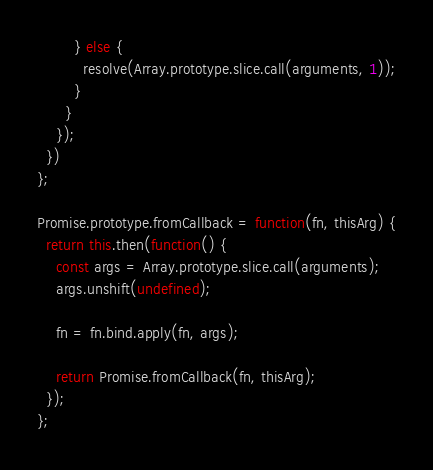Convert code to text. <code><loc_0><loc_0><loc_500><loc_500><_JavaScript_>        } else {
          resolve(Array.prototype.slice.call(arguments, 1));
        }
      }
    });
  })
};

Promise.prototype.fromCallback = function(fn, thisArg) {
  return this.then(function() {
    const args = Array.prototype.slice.call(arguments);
    args.unshift(undefined);

    fn = fn.bind.apply(fn, args);

    return Promise.fromCallback(fn, thisArg);
  });
};</code> 